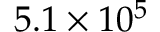Convert formula to latex. <formula><loc_0><loc_0><loc_500><loc_500>5 . 1 \times 1 0 ^ { 5 }</formula> 